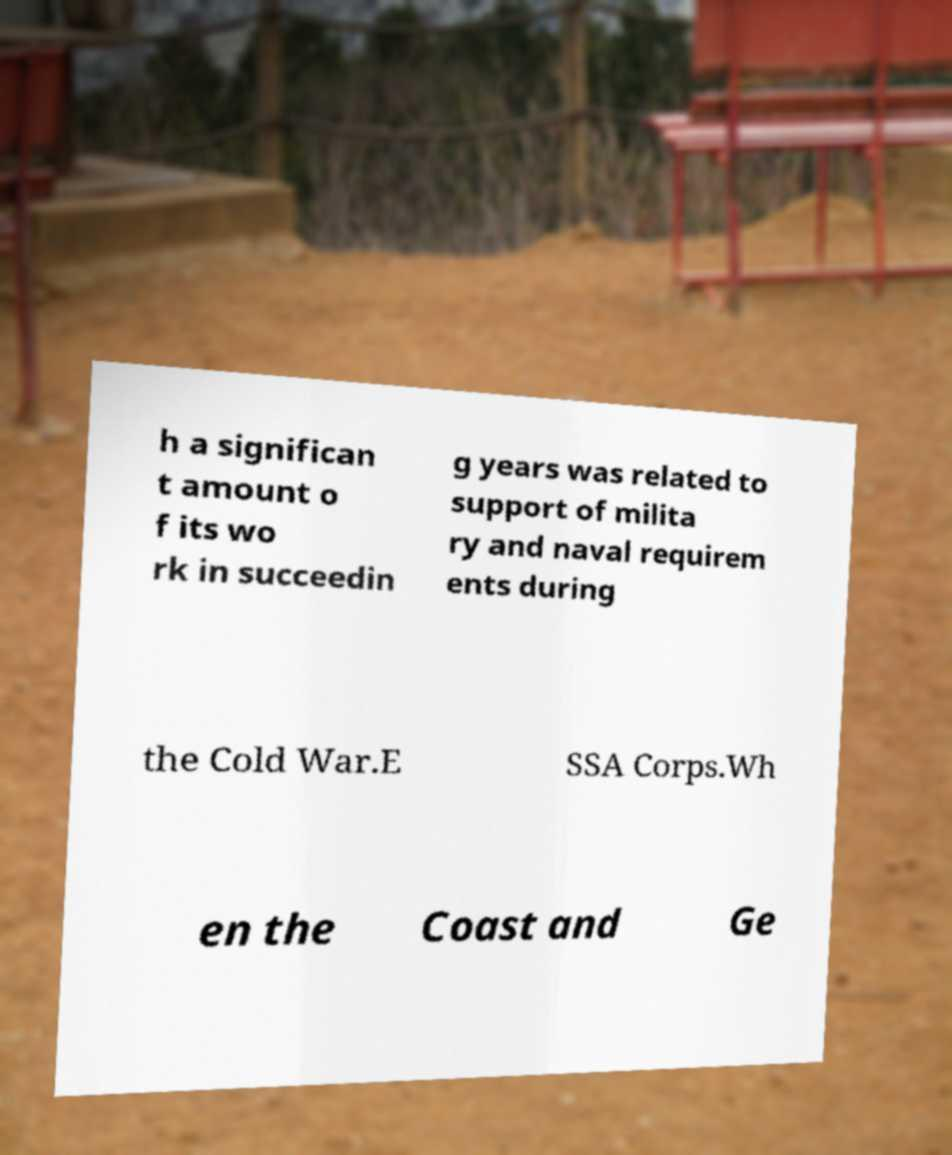Can you accurately transcribe the text from the provided image for me? h a significan t amount o f its wo rk in succeedin g years was related to support of milita ry and naval requirem ents during the Cold War.E SSA Corps.Wh en the Coast and Ge 